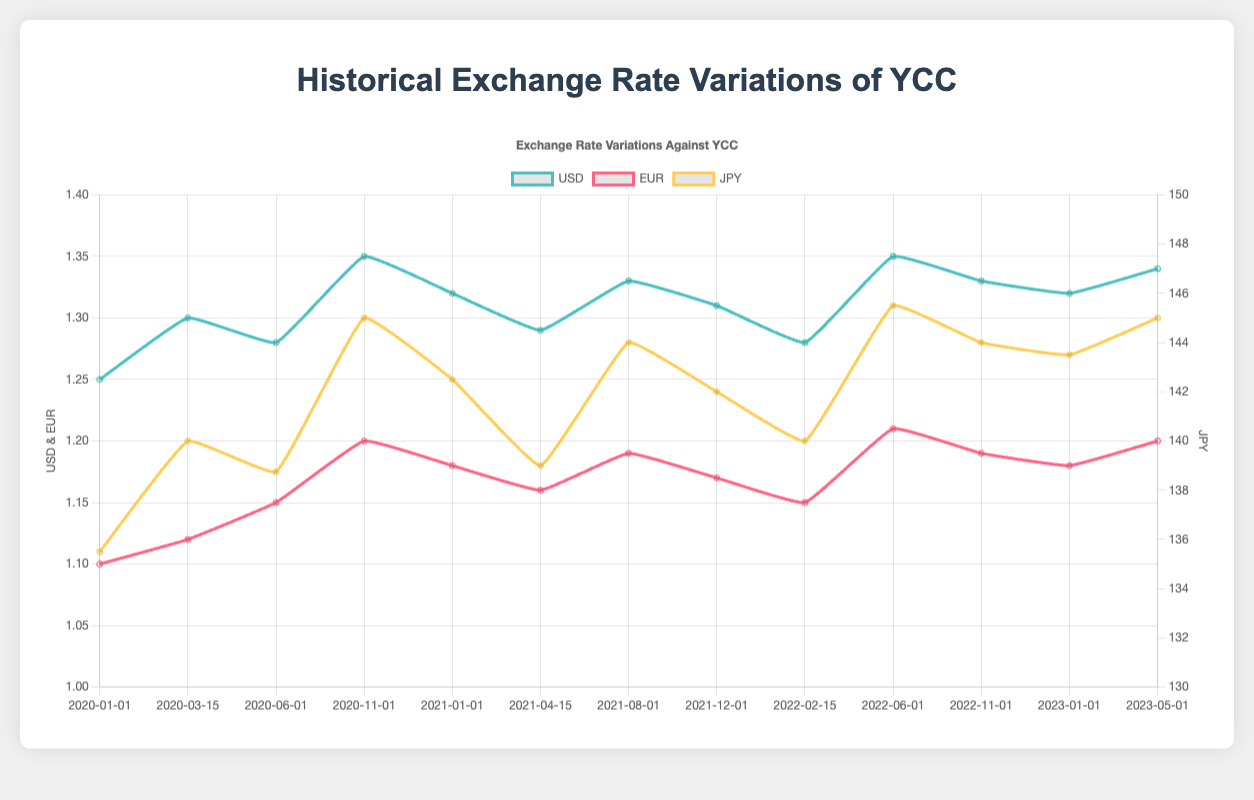What's the notable event that corresponds with the highest USD exchange rate? To find the highest USD exchange rate, we look for the peak point on the USD curve. The peak appears around "2022-06-01" with a rate of 1.35. The associated notable event is "Inflation concerns and interest rate hikes."
Answer: Inflation concerns and interest rate hikes Which currency showed the greatest increase from "2020-01-01" to "2020-11-01"? Compare the differences in exchange rates for USD, EUR, and JPY between the dates "2020-01-01" and "2020-11-01". The differences are: USD: 1.35 - 1.25 = 0.10, EUR: 1.20 - 1.10 = 0.10, JPY: 145.00 - 135.50 = 9.50. JPY increased the most by 9.50.
Answer: JPY What was the exchange rate for EUR on "2021-08-01"? Locate the EUR curve on "2021-08-01". The exchange rate at this point is listed as 1.19.
Answer: 1.19 How did the approval and rollout of COVID-19 vaccines impact the USD exchange rate? Identify the notable event "Approval and rollout of COVID-19 vaccines" on "2021-01-01". The USD exchange rate at this point was 1.32. Compare it to the previous and subsequent points. Earlier, it was 1.35 on "2020-11-01" and later 1.29 on "2021-04-15". The rate decreased initially and slightly increased again.
Answer: Decreased initially then slightly increased What's the average JPY exchange rate from "2022-06-01" to "2023-01-01"? Take the JPY rates at "2022-06-01" (145.50) and "2023-01-01" (143.50) and calculate the average: (145.50 + 143.50) / 2 = 144.50.
Answer: 144.50 Which currency had the smallest variance in exchange rates between the dates provided? Calculate the range (maximum - minimum) for USD, EUR, and JPY. USD: 1.35 - 1.25 = 0.10, EUR: 1.21 - 1.10 = 0.11, JPY: 145.50 - 135.50 = 10.00. USD has the smallest variance of 0.10.
Answer: USD What are the features of the two scales used in the chart? The chart uses two y-axes: the left y-axis represents USD and EUR rates ranging from 1 to 1.4, and the right y-axis represents JPY rates ranging from 130 to 150.
Answer: Two y-axes: USD & EUR (1-1.4) and JPY (130-150) Which event corresponds to the minimum JPY exchange rate shown? The minimum JPY exchange rate on the graph is 135.50 on "2020-01-01", and the event is the "Start of COVID-19 pandemic."
Answer: Start of COVID-19 pandemic 